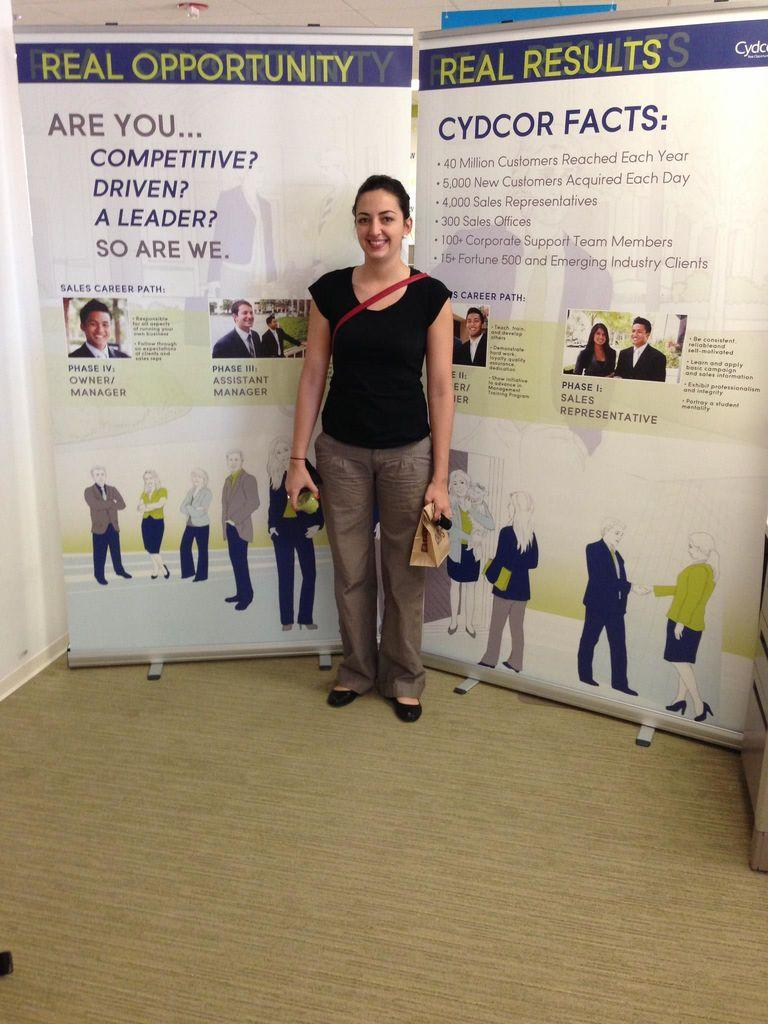Who is present in the image? There is a woman in the image. What is the woman doing in the image? The woman is standing and smiling. What can be seen in the background of the image? There are boards in the background of the image. What type of dinner is being served on the kite in the image? There is no kite or dinner present in the image. 